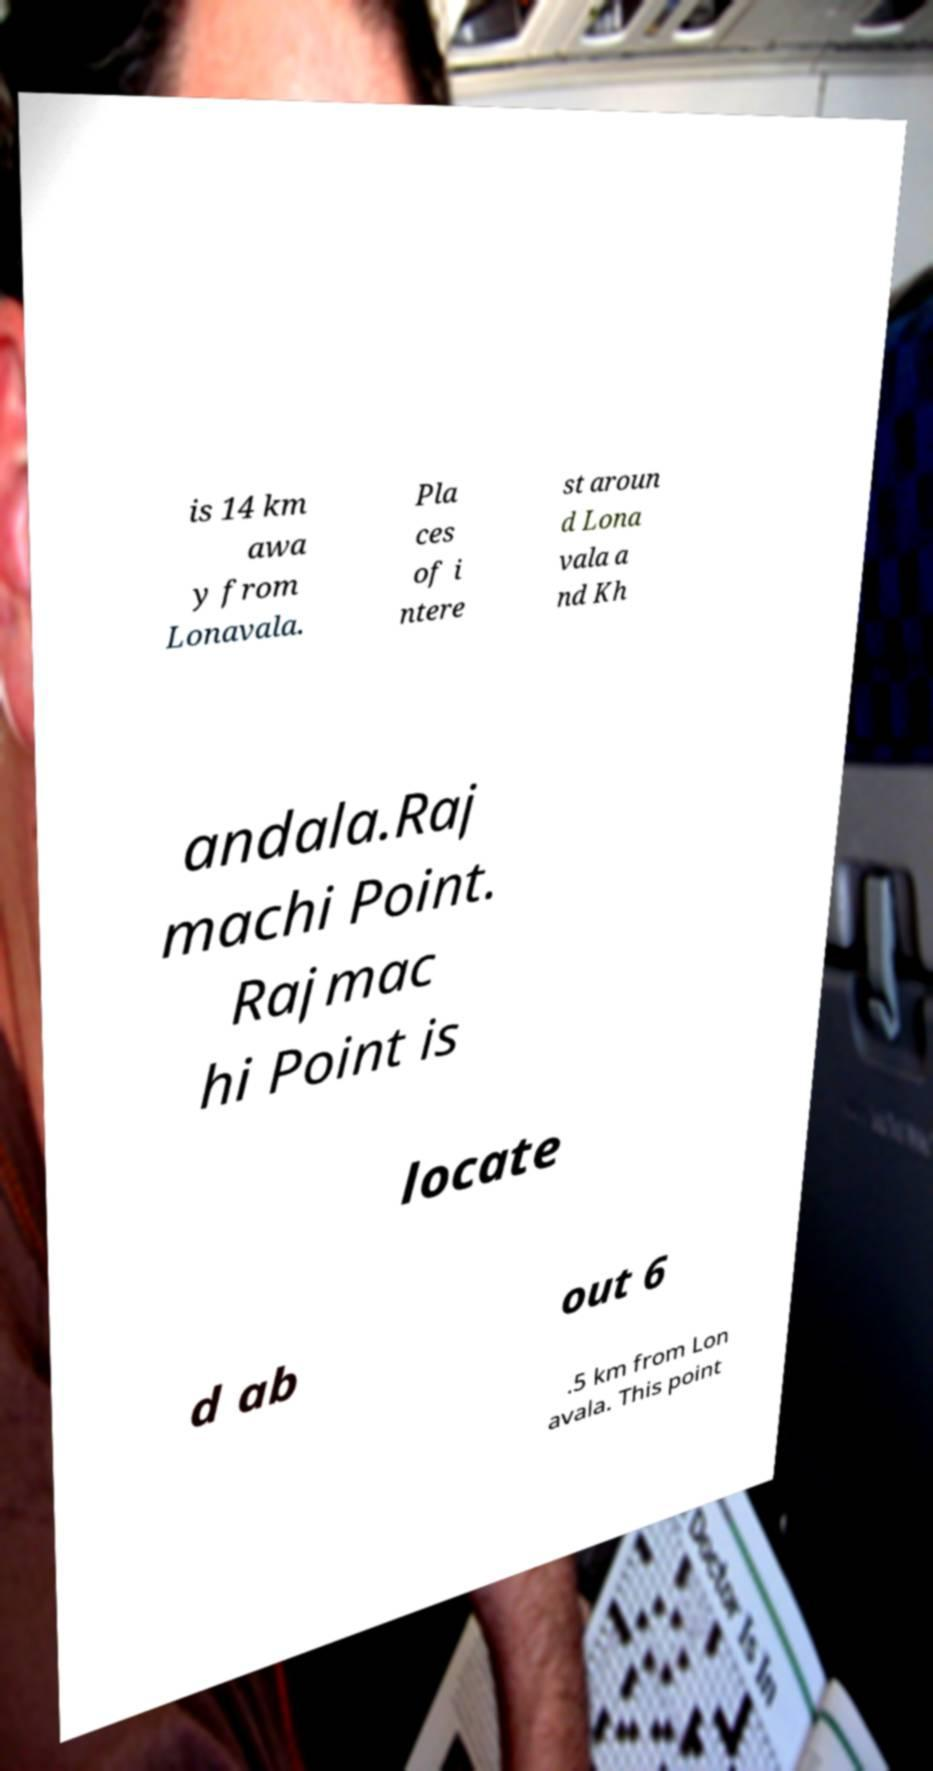Could you assist in decoding the text presented in this image and type it out clearly? is 14 km awa y from Lonavala. Pla ces of i ntere st aroun d Lona vala a nd Kh andala.Raj machi Point. Rajmac hi Point is locate d ab out 6 .5 km from Lon avala. This point 